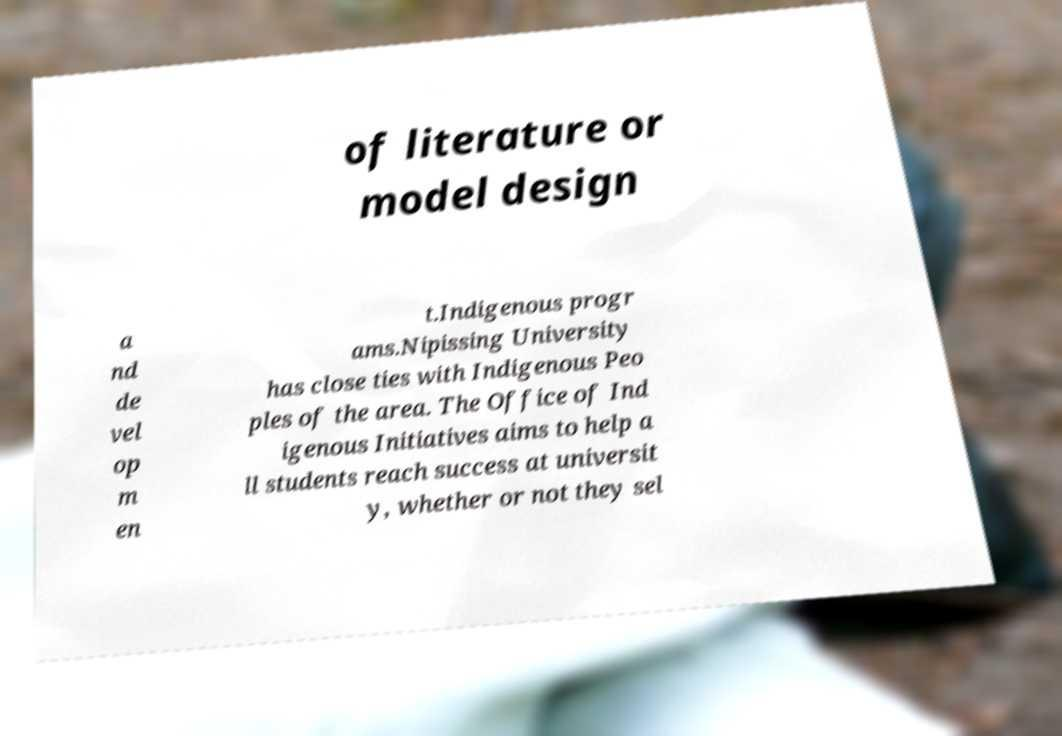There's text embedded in this image that I need extracted. Can you transcribe it verbatim? of literature or model design a nd de vel op m en t.Indigenous progr ams.Nipissing University has close ties with Indigenous Peo ples of the area. The Office of Ind igenous Initiatives aims to help a ll students reach success at universit y, whether or not they sel 